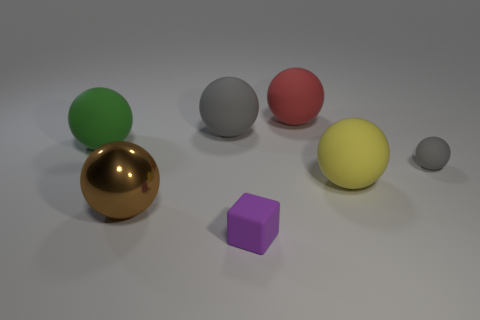There is a gray sphere on the right side of the big matte object that is in front of the small sphere; are there any large things in front of it?
Provide a short and direct response. Yes. There is a small rubber cube; is its color the same as the large sphere that is left of the metal object?
Your answer should be very brief. No. How many large matte things have the same color as the big metal ball?
Your answer should be compact. 0. What is the size of the brown ball that is left of the large matte object in front of the green object?
Make the answer very short. Large. How many objects are either matte spheres to the left of the block or yellow metal objects?
Give a very brief answer. 2. Is there a yellow matte sphere of the same size as the brown shiny ball?
Keep it short and to the point. Yes. Is there a rubber thing that is to the left of the gray matte thing to the left of the cube?
Your answer should be compact. Yes. How many spheres are either large red matte things or gray matte things?
Your answer should be very brief. 3. Are there any large purple rubber objects of the same shape as the green rubber object?
Ensure brevity in your answer.  No. The large shiny object is what shape?
Offer a very short reply. Sphere. 